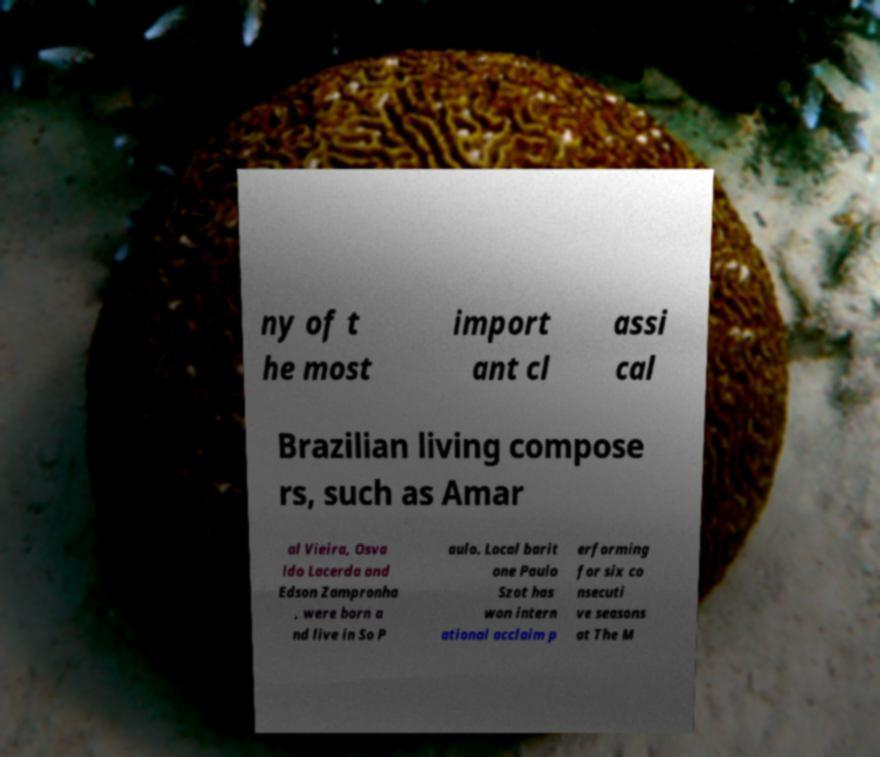Can you read and provide the text displayed in the image?This photo seems to have some interesting text. Can you extract and type it out for me? ny of t he most import ant cl assi cal Brazilian living compose rs, such as Amar al Vieira, Osva ldo Lacerda and Edson Zampronha , were born a nd live in So P aulo. Local barit one Paulo Szot has won intern ational acclaim p erforming for six co nsecuti ve seasons at The M 